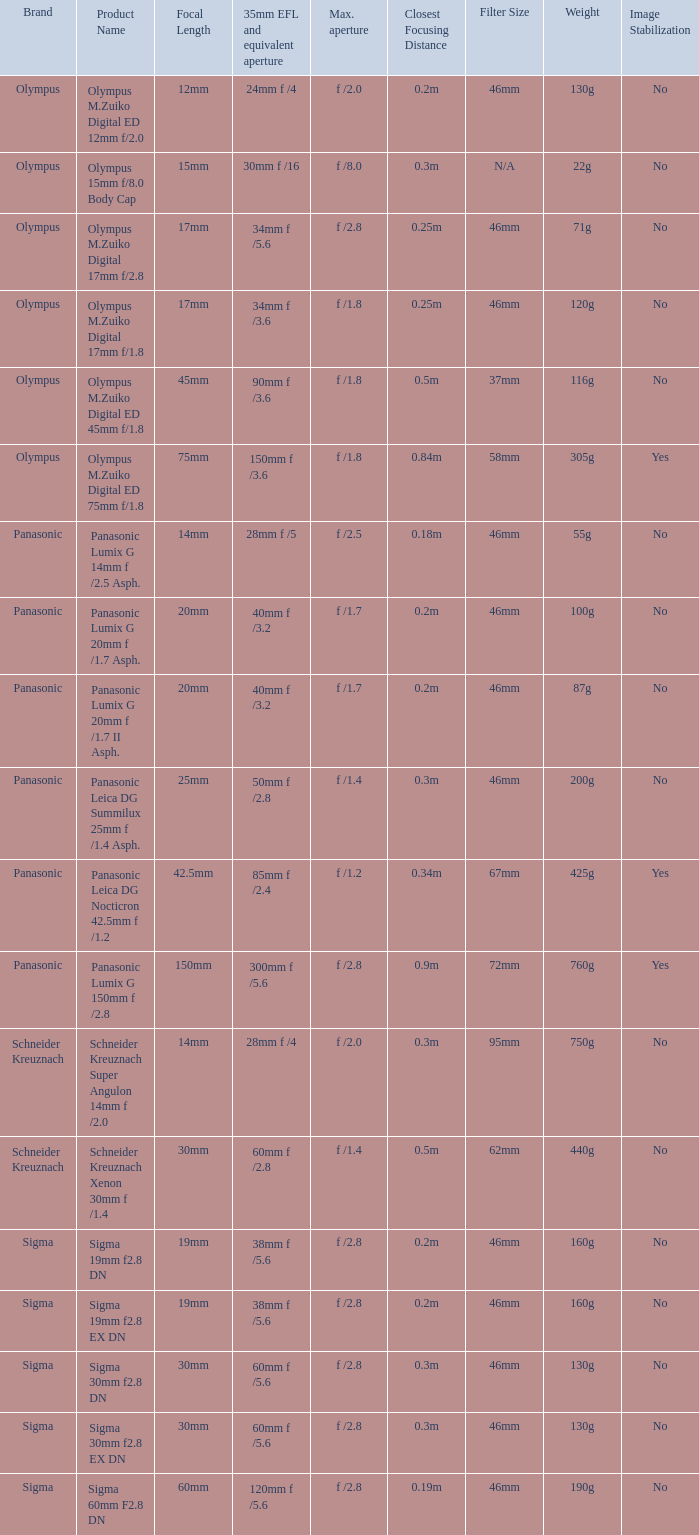What is the brand of the Sigma 30mm f2.8 DN, which has a maximum aperture of f /2.8 and a focal length of 30mm? Sigma. 